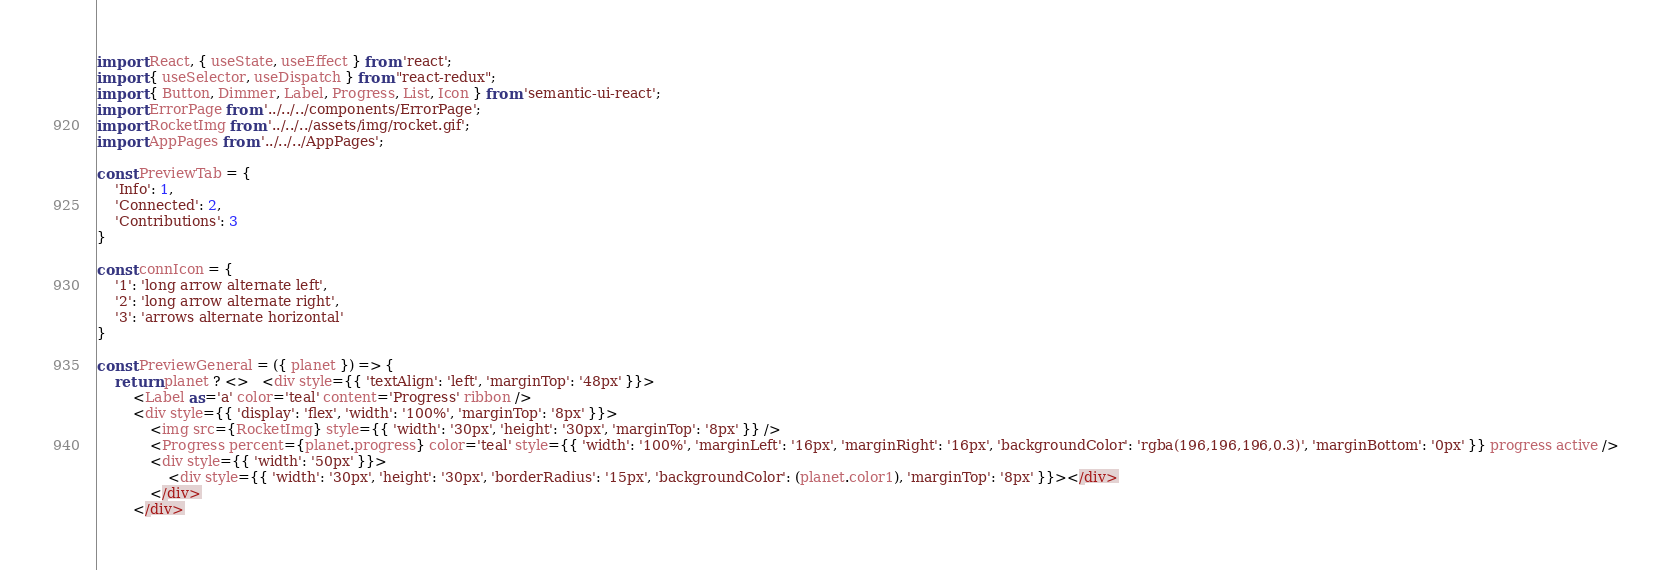Convert code to text. <code><loc_0><loc_0><loc_500><loc_500><_JavaScript_>import React, { useState, useEffect } from 'react';
import { useSelector, useDispatch } from "react-redux";
import { Button, Dimmer, Label, Progress, List, Icon } from 'semantic-ui-react';
import ErrorPage from '../../../components/ErrorPage';
import RocketImg from '../../../assets/img/rocket.gif';
import AppPages from '../../../AppPages';

const PreviewTab = {
    'Info': 1,
    'Connected': 2,
    'Contributions': 3
}

const connIcon = {
    '1': 'long arrow alternate left',
    '2': 'long arrow alternate right',
    '3': 'arrows alternate horizontal'
}

const PreviewGeneral = ({ planet }) => {
    return planet ? <>   <div style={{ 'textAlign': 'left', 'marginTop': '48px' }}>
        <Label as='a' color='teal' content='Progress' ribbon />
        <div style={{ 'display': 'flex', 'width': '100%', 'marginTop': '8px' }}>
            <img src={RocketImg} style={{ 'width': '30px', 'height': '30px', 'marginTop': '8px' }} />
            <Progress percent={planet.progress} color='teal' style={{ 'width': '100%', 'marginLeft': '16px', 'marginRight': '16px', 'backgroundColor': 'rgba(196,196,196,0.3)', 'marginBottom': '0px' }} progress active />
            <div style={{ 'width': '50px' }}>
                <div style={{ 'width': '30px', 'height': '30px', 'borderRadius': '15px', 'backgroundColor': (planet.color1), 'marginTop': '8px' }}></div>
            </div>
        </div></code> 